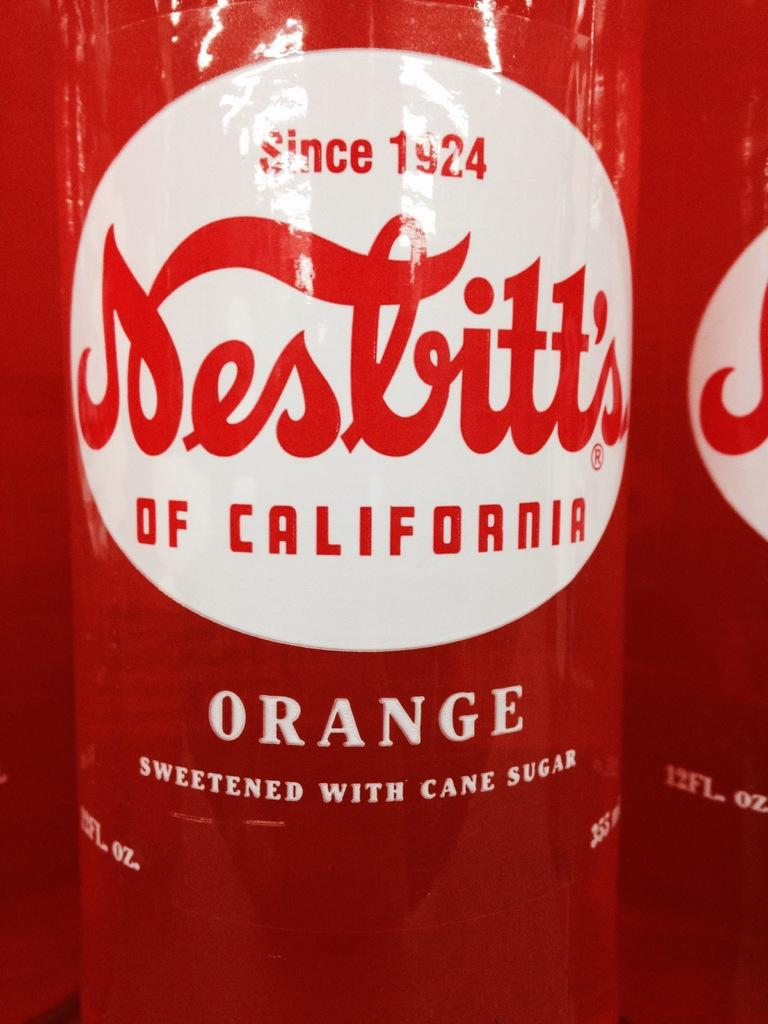<image>
Present a compact description of the photo's key features. bottle of orange soda from California are un opened 